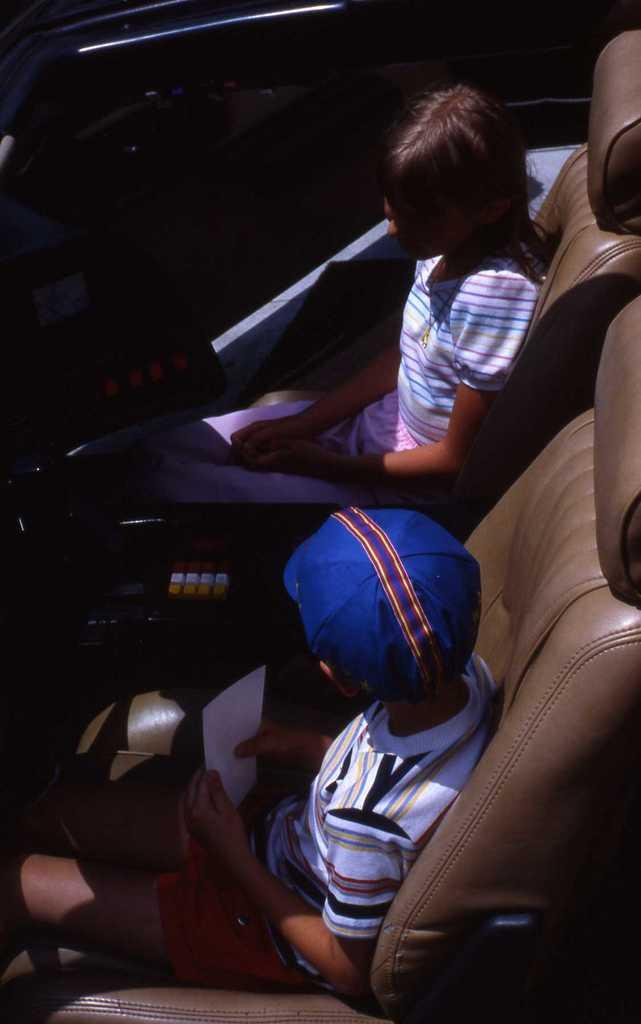How many people are in the image? There are two persons in the image. What are the persons doing in the image? Both persons are sitting on chairs. What is the person on the left holding? The person on the left is holding a paper. Can you describe the appearance of the person holding the paper? The person holding the paper is wearing a cap. What type of lake can be seen in the background of the image? There is no lake present in the image. How is the person on the right using the paper? The person on the right is not using the paper in any visible way in the image. 